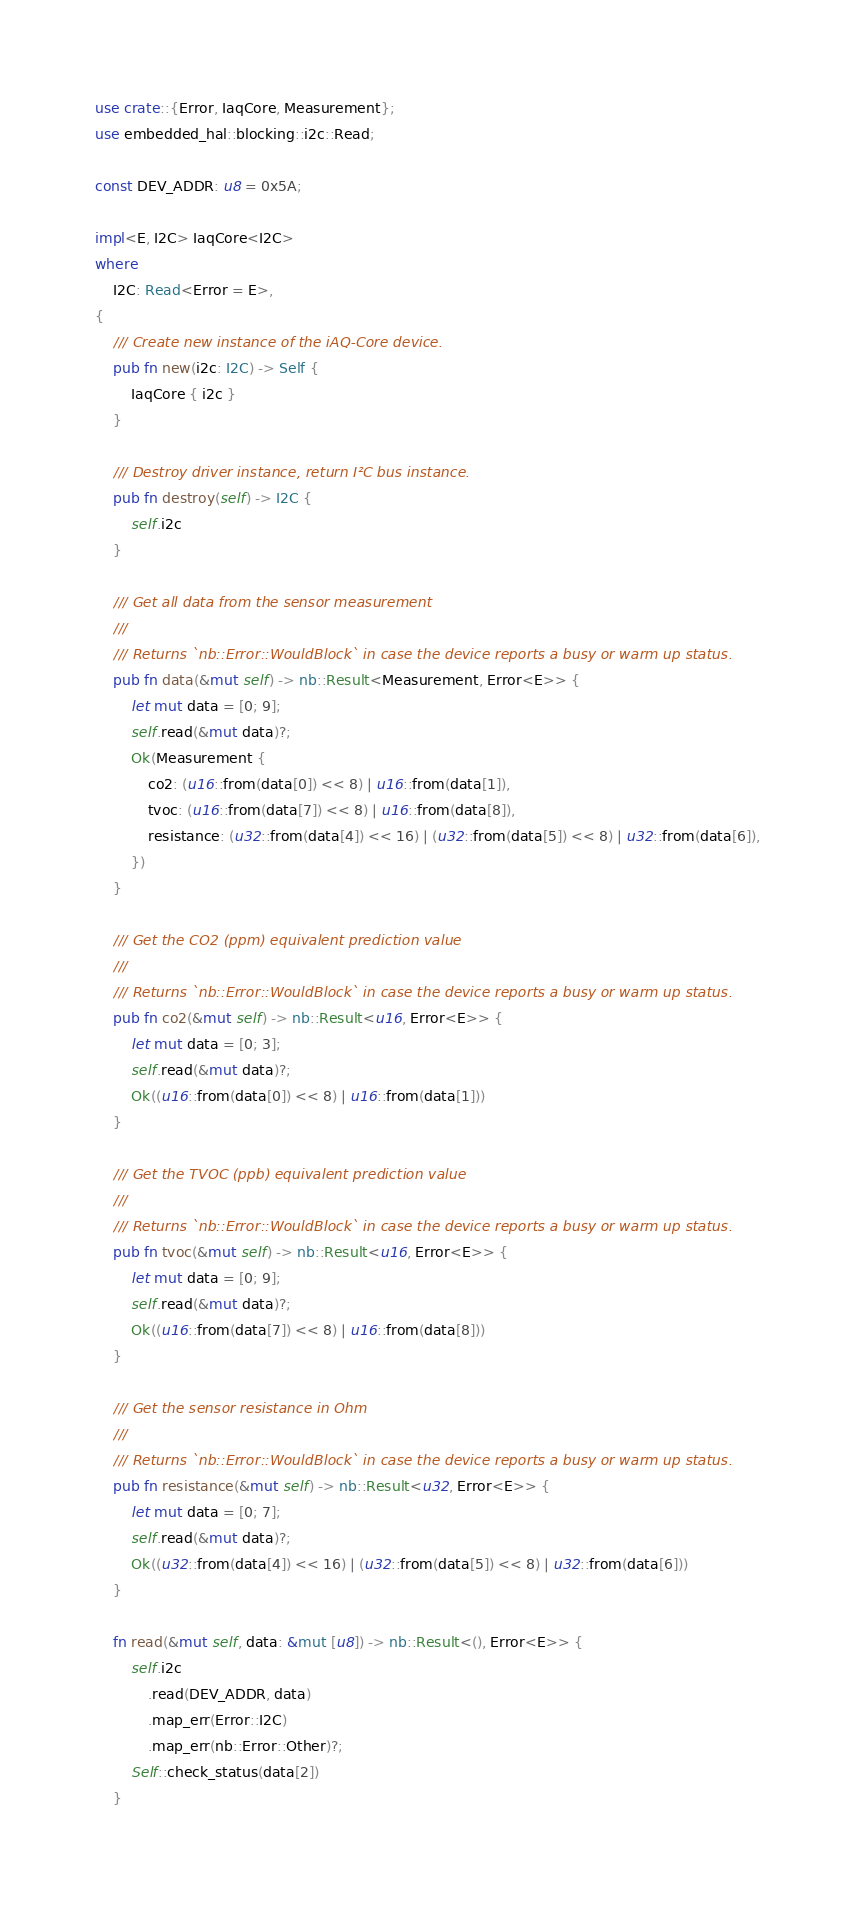Convert code to text. <code><loc_0><loc_0><loc_500><loc_500><_Rust_>use crate::{Error, IaqCore, Measurement};
use embedded_hal::blocking::i2c::Read;

const DEV_ADDR: u8 = 0x5A;

impl<E, I2C> IaqCore<I2C>
where
    I2C: Read<Error = E>,
{
    /// Create new instance of the iAQ-Core device.
    pub fn new(i2c: I2C) -> Self {
        IaqCore { i2c }
    }

    /// Destroy driver instance, return I²C bus instance.
    pub fn destroy(self) -> I2C {
        self.i2c
    }

    /// Get all data from the sensor measurement
    ///
    /// Returns `nb::Error::WouldBlock` in case the device reports a busy or warm up status.
    pub fn data(&mut self) -> nb::Result<Measurement, Error<E>> {
        let mut data = [0; 9];
        self.read(&mut data)?;
        Ok(Measurement {
            co2: (u16::from(data[0]) << 8) | u16::from(data[1]),
            tvoc: (u16::from(data[7]) << 8) | u16::from(data[8]),
            resistance: (u32::from(data[4]) << 16) | (u32::from(data[5]) << 8) | u32::from(data[6]),
        })
    }

    /// Get the CO2 (ppm) equivalent prediction value
    ///
    /// Returns `nb::Error::WouldBlock` in case the device reports a busy or warm up status.
    pub fn co2(&mut self) -> nb::Result<u16, Error<E>> {
        let mut data = [0; 3];
        self.read(&mut data)?;
        Ok((u16::from(data[0]) << 8) | u16::from(data[1]))
    }

    /// Get the TVOC (ppb) equivalent prediction value
    ///
    /// Returns `nb::Error::WouldBlock` in case the device reports a busy or warm up status.
    pub fn tvoc(&mut self) -> nb::Result<u16, Error<E>> {
        let mut data = [0; 9];
        self.read(&mut data)?;
        Ok((u16::from(data[7]) << 8) | u16::from(data[8]))
    }

    /// Get the sensor resistance in Ohm
    ///
    /// Returns `nb::Error::WouldBlock` in case the device reports a busy or warm up status.
    pub fn resistance(&mut self) -> nb::Result<u32, Error<E>> {
        let mut data = [0; 7];
        self.read(&mut data)?;
        Ok((u32::from(data[4]) << 16) | (u32::from(data[5]) << 8) | u32::from(data[6]))
    }

    fn read(&mut self, data: &mut [u8]) -> nb::Result<(), Error<E>> {
        self.i2c
            .read(DEV_ADDR, data)
            .map_err(Error::I2C)
            .map_err(nb::Error::Other)?;
        Self::check_status(data[2])
    }
</code> 